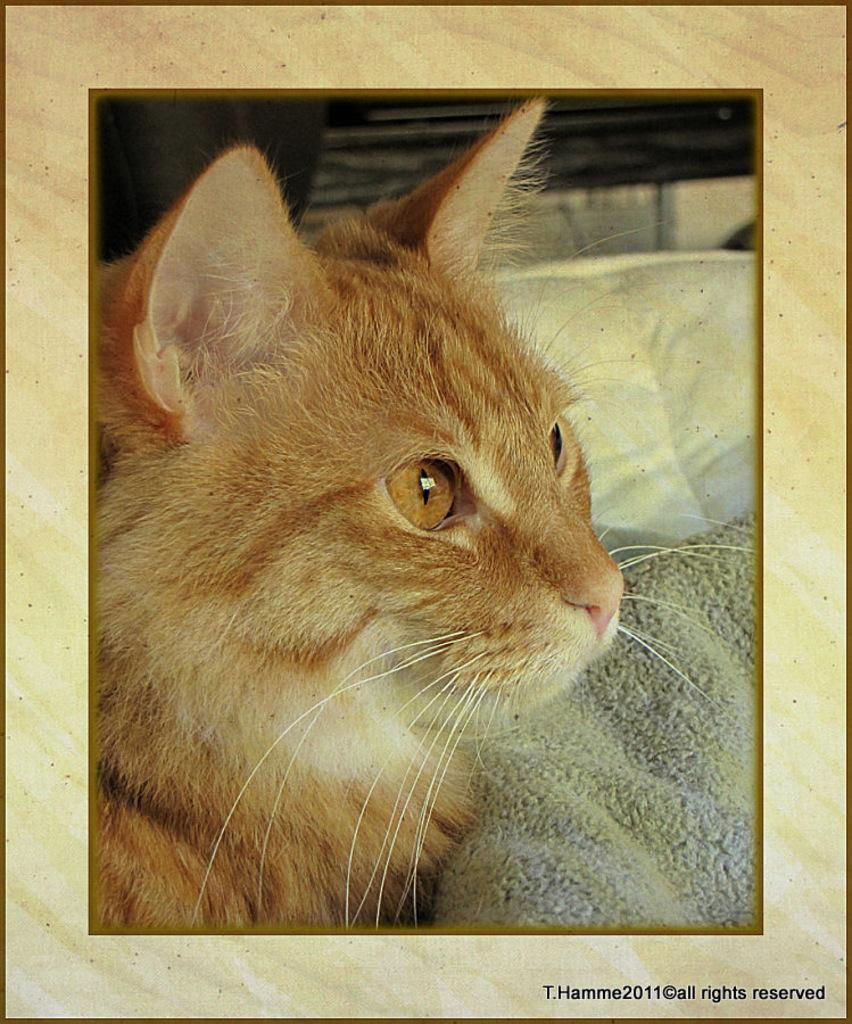What object is present in the image that typically holds a photograph? There is a photo frame in the image. What is depicted inside the photo frame? There is a cat in the photo frame. What is the cat doing in the photo frame? The cat is sleeping. What is the cat resting on in the photo frame? The cat is on a blanket. What type of gold jewelry is the cat wearing in the image? There is no gold jewelry present on the cat in the image. 